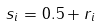Convert formula to latex. <formula><loc_0><loc_0><loc_500><loc_500>s _ { i } = 0 . 5 + r _ { i }</formula> 